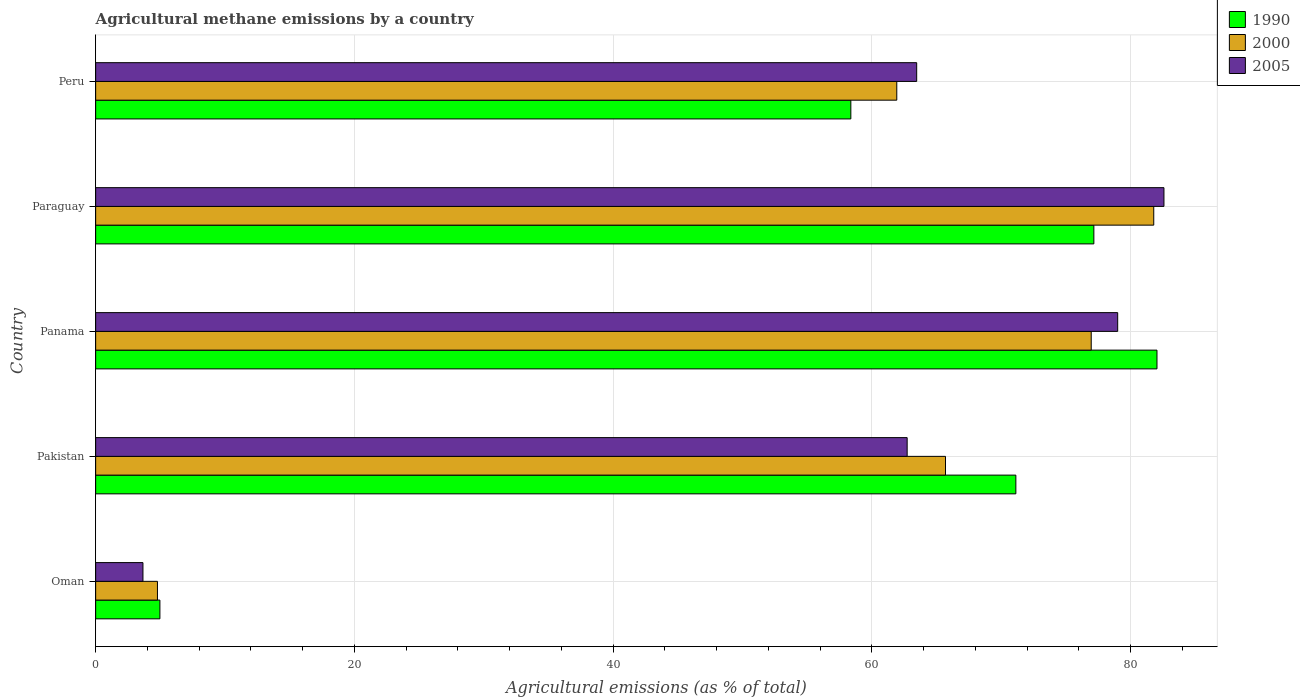How many different coloured bars are there?
Ensure brevity in your answer.  3. How many groups of bars are there?
Give a very brief answer. 5. Are the number of bars per tick equal to the number of legend labels?
Offer a very short reply. Yes. Are the number of bars on each tick of the Y-axis equal?
Your answer should be very brief. Yes. How many bars are there on the 1st tick from the bottom?
Offer a terse response. 3. What is the label of the 3rd group of bars from the top?
Offer a terse response. Panama. What is the amount of agricultural methane emitted in 1990 in Panama?
Provide a succinct answer. 82.04. Across all countries, what is the maximum amount of agricultural methane emitted in 1990?
Ensure brevity in your answer.  82.04. Across all countries, what is the minimum amount of agricultural methane emitted in 2005?
Your answer should be very brief. 3.66. In which country was the amount of agricultural methane emitted in 2000 maximum?
Make the answer very short. Paraguay. In which country was the amount of agricultural methane emitted in 2005 minimum?
Your answer should be very brief. Oman. What is the total amount of agricultural methane emitted in 2000 in the graph?
Provide a short and direct response. 291.14. What is the difference between the amount of agricultural methane emitted in 2005 in Oman and that in Pakistan?
Offer a terse response. -59.07. What is the difference between the amount of agricultural methane emitted in 2000 in Pakistan and the amount of agricultural methane emitted in 2005 in Oman?
Offer a terse response. 62.04. What is the average amount of agricultural methane emitted in 2000 per country?
Your answer should be very brief. 58.23. What is the difference between the amount of agricultural methane emitted in 1990 and amount of agricultural methane emitted in 2005 in Oman?
Your answer should be very brief. 1.31. What is the ratio of the amount of agricultural methane emitted in 1990 in Oman to that in Pakistan?
Your answer should be very brief. 0.07. What is the difference between the highest and the second highest amount of agricultural methane emitted in 2000?
Your answer should be compact. 4.83. What is the difference between the highest and the lowest amount of agricultural methane emitted in 1990?
Ensure brevity in your answer.  77.07. In how many countries, is the amount of agricultural methane emitted in 2000 greater than the average amount of agricultural methane emitted in 2000 taken over all countries?
Your answer should be very brief. 4. Is the sum of the amount of agricultural methane emitted in 2005 in Oman and Pakistan greater than the maximum amount of agricultural methane emitted in 1990 across all countries?
Offer a very short reply. No. What does the 2nd bar from the bottom in Pakistan represents?
Make the answer very short. 2000. How many countries are there in the graph?
Give a very brief answer. 5. What is the difference between two consecutive major ticks on the X-axis?
Provide a short and direct response. 20. Does the graph contain any zero values?
Provide a succinct answer. No. How many legend labels are there?
Your answer should be compact. 3. What is the title of the graph?
Your response must be concise. Agricultural methane emissions by a country. Does "1971" appear as one of the legend labels in the graph?
Offer a very short reply. No. What is the label or title of the X-axis?
Offer a terse response. Agricultural emissions (as % of total). What is the label or title of the Y-axis?
Provide a short and direct response. Country. What is the Agricultural emissions (as % of total) in 1990 in Oman?
Make the answer very short. 4.97. What is the Agricultural emissions (as % of total) of 2000 in Oman?
Offer a very short reply. 4.78. What is the Agricultural emissions (as % of total) in 2005 in Oman?
Offer a very short reply. 3.66. What is the Agricultural emissions (as % of total) of 1990 in Pakistan?
Your response must be concise. 71.13. What is the Agricultural emissions (as % of total) in 2000 in Pakistan?
Your response must be concise. 65.69. What is the Agricultural emissions (as % of total) in 2005 in Pakistan?
Offer a terse response. 62.73. What is the Agricultural emissions (as % of total) of 1990 in Panama?
Your answer should be compact. 82.04. What is the Agricultural emissions (as % of total) in 2000 in Panama?
Provide a short and direct response. 76.96. What is the Agricultural emissions (as % of total) in 2005 in Panama?
Make the answer very short. 79. What is the Agricultural emissions (as % of total) of 1990 in Paraguay?
Your answer should be very brief. 77.16. What is the Agricultural emissions (as % of total) of 2000 in Paraguay?
Provide a succinct answer. 81.79. What is the Agricultural emissions (as % of total) of 2005 in Paraguay?
Provide a short and direct response. 82.58. What is the Agricultural emissions (as % of total) in 1990 in Peru?
Ensure brevity in your answer.  58.38. What is the Agricultural emissions (as % of total) in 2000 in Peru?
Offer a very short reply. 61.93. What is the Agricultural emissions (as % of total) of 2005 in Peru?
Provide a short and direct response. 63.46. Across all countries, what is the maximum Agricultural emissions (as % of total) in 1990?
Ensure brevity in your answer.  82.04. Across all countries, what is the maximum Agricultural emissions (as % of total) of 2000?
Offer a very short reply. 81.79. Across all countries, what is the maximum Agricultural emissions (as % of total) of 2005?
Make the answer very short. 82.58. Across all countries, what is the minimum Agricultural emissions (as % of total) of 1990?
Keep it short and to the point. 4.97. Across all countries, what is the minimum Agricultural emissions (as % of total) of 2000?
Give a very brief answer. 4.78. Across all countries, what is the minimum Agricultural emissions (as % of total) of 2005?
Your response must be concise. 3.66. What is the total Agricultural emissions (as % of total) of 1990 in the graph?
Ensure brevity in your answer.  293.67. What is the total Agricultural emissions (as % of total) of 2000 in the graph?
Make the answer very short. 291.14. What is the total Agricultural emissions (as % of total) in 2005 in the graph?
Make the answer very short. 291.43. What is the difference between the Agricultural emissions (as % of total) in 1990 in Oman and that in Pakistan?
Ensure brevity in your answer.  -66.16. What is the difference between the Agricultural emissions (as % of total) in 2000 in Oman and that in Pakistan?
Provide a succinct answer. -60.92. What is the difference between the Agricultural emissions (as % of total) in 2005 in Oman and that in Pakistan?
Your answer should be very brief. -59.07. What is the difference between the Agricultural emissions (as % of total) of 1990 in Oman and that in Panama?
Your answer should be compact. -77.07. What is the difference between the Agricultural emissions (as % of total) in 2000 in Oman and that in Panama?
Offer a terse response. -72.18. What is the difference between the Agricultural emissions (as % of total) in 2005 in Oman and that in Panama?
Give a very brief answer. -75.35. What is the difference between the Agricultural emissions (as % of total) in 1990 in Oman and that in Paraguay?
Your answer should be very brief. -72.19. What is the difference between the Agricultural emissions (as % of total) in 2000 in Oman and that in Paraguay?
Your answer should be compact. -77.01. What is the difference between the Agricultural emissions (as % of total) in 2005 in Oman and that in Paraguay?
Offer a terse response. -78.92. What is the difference between the Agricultural emissions (as % of total) of 1990 in Oman and that in Peru?
Offer a very short reply. -53.41. What is the difference between the Agricultural emissions (as % of total) in 2000 in Oman and that in Peru?
Keep it short and to the point. -57.15. What is the difference between the Agricultural emissions (as % of total) of 2005 in Oman and that in Peru?
Your answer should be compact. -59.81. What is the difference between the Agricultural emissions (as % of total) in 1990 in Pakistan and that in Panama?
Provide a short and direct response. -10.91. What is the difference between the Agricultural emissions (as % of total) in 2000 in Pakistan and that in Panama?
Your response must be concise. -11.26. What is the difference between the Agricultural emissions (as % of total) in 2005 in Pakistan and that in Panama?
Keep it short and to the point. -16.27. What is the difference between the Agricultural emissions (as % of total) of 1990 in Pakistan and that in Paraguay?
Provide a short and direct response. -6.03. What is the difference between the Agricultural emissions (as % of total) in 2000 in Pakistan and that in Paraguay?
Ensure brevity in your answer.  -16.1. What is the difference between the Agricultural emissions (as % of total) in 2005 in Pakistan and that in Paraguay?
Provide a short and direct response. -19.85. What is the difference between the Agricultural emissions (as % of total) of 1990 in Pakistan and that in Peru?
Give a very brief answer. 12.76. What is the difference between the Agricultural emissions (as % of total) of 2000 in Pakistan and that in Peru?
Your answer should be very brief. 3.77. What is the difference between the Agricultural emissions (as % of total) in 2005 in Pakistan and that in Peru?
Provide a short and direct response. -0.74. What is the difference between the Agricultural emissions (as % of total) in 1990 in Panama and that in Paraguay?
Make the answer very short. 4.88. What is the difference between the Agricultural emissions (as % of total) of 2000 in Panama and that in Paraguay?
Make the answer very short. -4.83. What is the difference between the Agricultural emissions (as % of total) of 2005 in Panama and that in Paraguay?
Ensure brevity in your answer.  -3.58. What is the difference between the Agricultural emissions (as % of total) in 1990 in Panama and that in Peru?
Make the answer very short. 23.66. What is the difference between the Agricultural emissions (as % of total) of 2000 in Panama and that in Peru?
Provide a succinct answer. 15.03. What is the difference between the Agricultural emissions (as % of total) of 2005 in Panama and that in Peru?
Provide a succinct answer. 15.54. What is the difference between the Agricultural emissions (as % of total) in 1990 in Paraguay and that in Peru?
Give a very brief answer. 18.78. What is the difference between the Agricultural emissions (as % of total) in 2000 in Paraguay and that in Peru?
Provide a short and direct response. 19.86. What is the difference between the Agricultural emissions (as % of total) in 2005 in Paraguay and that in Peru?
Your answer should be very brief. 19.11. What is the difference between the Agricultural emissions (as % of total) in 1990 in Oman and the Agricultural emissions (as % of total) in 2000 in Pakistan?
Keep it short and to the point. -60.73. What is the difference between the Agricultural emissions (as % of total) of 1990 in Oman and the Agricultural emissions (as % of total) of 2005 in Pakistan?
Your response must be concise. -57.76. What is the difference between the Agricultural emissions (as % of total) of 2000 in Oman and the Agricultural emissions (as % of total) of 2005 in Pakistan?
Offer a very short reply. -57.95. What is the difference between the Agricultural emissions (as % of total) of 1990 in Oman and the Agricultural emissions (as % of total) of 2000 in Panama?
Offer a terse response. -71.99. What is the difference between the Agricultural emissions (as % of total) in 1990 in Oman and the Agricultural emissions (as % of total) in 2005 in Panama?
Ensure brevity in your answer.  -74.03. What is the difference between the Agricultural emissions (as % of total) in 2000 in Oman and the Agricultural emissions (as % of total) in 2005 in Panama?
Your answer should be compact. -74.23. What is the difference between the Agricultural emissions (as % of total) in 1990 in Oman and the Agricultural emissions (as % of total) in 2000 in Paraguay?
Make the answer very short. -76.82. What is the difference between the Agricultural emissions (as % of total) of 1990 in Oman and the Agricultural emissions (as % of total) of 2005 in Paraguay?
Provide a short and direct response. -77.61. What is the difference between the Agricultural emissions (as % of total) in 2000 in Oman and the Agricultural emissions (as % of total) in 2005 in Paraguay?
Give a very brief answer. -77.8. What is the difference between the Agricultural emissions (as % of total) of 1990 in Oman and the Agricultural emissions (as % of total) of 2000 in Peru?
Make the answer very short. -56.96. What is the difference between the Agricultural emissions (as % of total) of 1990 in Oman and the Agricultural emissions (as % of total) of 2005 in Peru?
Your answer should be very brief. -58.5. What is the difference between the Agricultural emissions (as % of total) in 2000 in Oman and the Agricultural emissions (as % of total) in 2005 in Peru?
Give a very brief answer. -58.69. What is the difference between the Agricultural emissions (as % of total) in 1990 in Pakistan and the Agricultural emissions (as % of total) in 2000 in Panama?
Offer a very short reply. -5.83. What is the difference between the Agricultural emissions (as % of total) of 1990 in Pakistan and the Agricultural emissions (as % of total) of 2005 in Panama?
Your response must be concise. -7.87. What is the difference between the Agricultural emissions (as % of total) of 2000 in Pakistan and the Agricultural emissions (as % of total) of 2005 in Panama?
Your response must be concise. -13.31. What is the difference between the Agricultural emissions (as % of total) of 1990 in Pakistan and the Agricultural emissions (as % of total) of 2000 in Paraguay?
Your response must be concise. -10.66. What is the difference between the Agricultural emissions (as % of total) of 1990 in Pakistan and the Agricultural emissions (as % of total) of 2005 in Paraguay?
Offer a very short reply. -11.45. What is the difference between the Agricultural emissions (as % of total) of 2000 in Pakistan and the Agricultural emissions (as % of total) of 2005 in Paraguay?
Ensure brevity in your answer.  -16.89. What is the difference between the Agricultural emissions (as % of total) in 1990 in Pakistan and the Agricultural emissions (as % of total) in 2000 in Peru?
Provide a succinct answer. 9.2. What is the difference between the Agricultural emissions (as % of total) in 1990 in Pakistan and the Agricultural emissions (as % of total) in 2005 in Peru?
Keep it short and to the point. 7.67. What is the difference between the Agricultural emissions (as % of total) in 2000 in Pakistan and the Agricultural emissions (as % of total) in 2005 in Peru?
Your answer should be very brief. 2.23. What is the difference between the Agricultural emissions (as % of total) of 1990 in Panama and the Agricultural emissions (as % of total) of 2000 in Paraguay?
Offer a very short reply. 0.25. What is the difference between the Agricultural emissions (as % of total) in 1990 in Panama and the Agricultural emissions (as % of total) in 2005 in Paraguay?
Make the answer very short. -0.54. What is the difference between the Agricultural emissions (as % of total) in 2000 in Panama and the Agricultural emissions (as % of total) in 2005 in Paraguay?
Offer a terse response. -5.62. What is the difference between the Agricultural emissions (as % of total) in 1990 in Panama and the Agricultural emissions (as % of total) in 2000 in Peru?
Give a very brief answer. 20.11. What is the difference between the Agricultural emissions (as % of total) in 1990 in Panama and the Agricultural emissions (as % of total) in 2005 in Peru?
Give a very brief answer. 18.58. What is the difference between the Agricultural emissions (as % of total) in 2000 in Panama and the Agricultural emissions (as % of total) in 2005 in Peru?
Your answer should be very brief. 13.49. What is the difference between the Agricultural emissions (as % of total) in 1990 in Paraguay and the Agricultural emissions (as % of total) in 2000 in Peru?
Keep it short and to the point. 15.23. What is the difference between the Agricultural emissions (as % of total) of 1990 in Paraguay and the Agricultural emissions (as % of total) of 2005 in Peru?
Keep it short and to the point. 13.7. What is the difference between the Agricultural emissions (as % of total) of 2000 in Paraguay and the Agricultural emissions (as % of total) of 2005 in Peru?
Provide a succinct answer. 18.33. What is the average Agricultural emissions (as % of total) of 1990 per country?
Give a very brief answer. 58.73. What is the average Agricultural emissions (as % of total) in 2000 per country?
Offer a terse response. 58.23. What is the average Agricultural emissions (as % of total) in 2005 per country?
Provide a short and direct response. 58.29. What is the difference between the Agricultural emissions (as % of total) in 1990 and Agricultural emissions (as % of total) in 2000 in Oman?
Provide a succinct answer. 0.19. What is the difference between the Agricultural emissions (as % of total) of 1990 and Agricultural emissions (as % of total) of 2005 in Oman?
Provide a short and direct response. 1.31. What is the difference between the Agricultural emissions (as % of total) of 2000 and Agricultural emissions (as % of total) of 2005 in Oman?
Provide a succinct answer. 1.12. What is the difference between the Agricultural emissions (as % of total) in 1990 and Agricultural emissions (as % of total) in 2000 in Pakistan?
Offer a very short reply. 5.44. What is the difference between the Agricultural emissions (as % of total) of 1990 and Agricultural emissions (as % of total) of 2005 in Pakistan?
Ensure brevity in your answer.  8.4. What is the difference between the Agricultural emissions (as % of total) in 2000 and Agricultural emissions (as % of total) in 2005 in Pakistan?
Give a very brief answer. 2.96. What is the difference between the Agricultural emissions (as % of total) of 1990 and Agricultural emissions (as % of total) of 2000 in Panama?
Your response must be concise. 5.08. What is the difference between the Agricultural emissions (as % of total) of 1990 and Agricultural emissions (as % of total) of 2005 in Panama?
Ensure brevity in your answer.  3.04. What is the difference between the Agricultural emissions (as % of total) in 2000 and Agricultural emissions (as % of total) in 2005 in Panama?
Your answer should be very brief. -2.04. What is the difference between the Agricultural emissions (as % of total) of 1990 and Agricultural emissions (as % of total) of 2000 in Paraguay?
Offer a terse response. -4.63. What is the difference between the Agricultural emissions (as % of total) of 1990 and Agricultural emissions (as % of total) of 2005 in Paraguay?
Ensure brevity in your answer.  -5.42. What is the difference between the Agricultural emissions (as % of total) of 2000 and Agricultural emissions (as % of total) of 2005 in Paraguay?
Your answer should be compact. -0.79. What is the difference between the Agricultural emissions (as % of total) of 1990 and Agricultural emissions (as % of total) of 2000 in Peru?
Make the answer very short. -3.55. What is the difference between the Agricultural emissions (as % of total) of 1990 and Agricultural emissions (as % of total) of 2005 in Peru?
Provide a succinct answer. -5.09. What is the difference between the Agricultural emissions (as % of total) of 2000 and Agricultural emissions (as % of total) of 2005 in Peru?
Make the answer very short. -1.54. What is the ratio of the Agricultural emissions (as % of total) in 1990 in Oman to that in Pakistan?
Ensure brevity in your answer.  0.07. What is the ratio of the Agricultural emissions (as % of total) of 2000 in Oman to that in Pakistan?
Provide a short and direct response. 0.07. What is the ratio of the Agricultural emissions (as % of total) of 2005 in Oman to that in Pakistan?
Provide a short and direct response. 0.06. What is the ratio of the Agricultural emissions (as % of total) in 1990 in Oman to that in Panama?
Make the answer very short. 0.06. What is the ratio of the Agricultural emissions (as % of total) in 2000 in Oman to that in Panama?
Give a very brief answer. 0.06. What is the ratio of the Agricultural emissions (as % of total) in 2005 in Oman to that in Panama?
Provide a short and direct response. 0.05. What is the ratio of the Agricultural emissions (as % of total) in 1990 in Oman to that in Paraguay?
Offer a terse response. 0.06. What is the ratio of the Agricultural emissions (as % of total) of 2000 in Oman to that in Paraguay?
Offer a terse response. 0.06. What is the ratio of the Agricultural emissions (as % of total) in 2005 in Oman to that in Paraguay?
Your answer should be compact. 0.04. What is the ratio of the Agricultural emissions (as % of total) in 1990 in Oman to that in Peru?
Your answer should be very brief. 0.09. What is the ratio of the Agricultural emissions (as % of total) in 2000 in Oman to that in Peru?
Provide a succinct answer. 0.08. What is the ratio of the Agricultural emissions (as % of total) in 2005 in Oman to that in Peru?
Ensure brevity in your answer.  0.06. What is the ratio of the Agricultural emissions (as % of total) of 1990 in Pakistan to that in Panama?
Provide a succinct answer. 0.87. What is the ratio of the Agricultural emissions (as % of total) in 2000 in Pakistan to that in Panama?
Your answer should be very brief. 0.85. What is the ratio of the Agricultural emissions (as % of total) of 2005 in Pakistan to that in Panama?
Offer a terse response. 0.79. What is the ratio of the Agricultural emissions (as % of total) of 1990 in Pakistan to that in Paraguay?
Offer a terse response. 0.92. What is the ratio of the Agricultural emissions (as % of total) of 2000 in Pakistan to that in Paraguay?
Ensure brevity in your answer.  0.8. What is the ratio of the Agricultural emissions (as % of total) in 2005 in Pakistan to that in Paraguay?
Give a very brief answer. 0.76. What is the ratio of the Agricultural emissions (as % of total) of 1990 in Pakistan to that in Peru?
Ensure brevity in your answer.  1.22. What is the ratio of the Agricultural emissions (as % of total) in 2000 in Pakistan to that in Peru?
Keep it short and to the point. 1.06. What is the ratio of the Agricultural emissions (as % of total) in 2005 in Pakistan to that in Peru?
Your answer should be very brief. 0.99. What is the ratio of the Agricultural emissions (as % of total) of 1990 in Panama to that in Paraguay?
Provide a short and direct response. 1.06. What is the ratio of the Agricultural emissions (as % of total) in 2000 in Panama to that in Paraguay?
Your response must be concise. 0.94. What is the ratio of the Agricultural emissions (as % of total) of 2005 in Panama to that in Paraguay?
Offer a terse response. 0.96. What is the ratio of the Agricultural emissions (as % of total) of 1990 in Panama to that in Peru?
Your response must be concise. 1.41. What is the ratio of the Agricultural emissions (as % of total) in 2000 in Panama to that in Peru?
Your response must be concise. 1.24. What is the ratio of the Agricultural emissions (as % of total) in 2005 in Panama to that in Peru?
Keep it short and to the point. 1.24. What is the ratio of the Agricultural emissions (as % of total) of 1990 in Paraguay to that in Peru?
Keep it short and to the point. 1.32. What is the ratio of the Agricultural emissions (as % of total) in 2000 in Paraguay to that in Peru?
Keep it short and to the point. 1.32. What is the ratio of the Agricultural emissions (as % of total) of 2005 in Paraguay to that in Peru?
Your answer should be compact. 1.3. What is the difference between the highest and the second highest Agricultural emissions (as % of total) of 1990?
Give a very brief answer. 4.88. What is the difference between the highest and the second highest Agricultural emissions (as % of total) in 2000?
Your answer should be very brief. 4.83. What is the difference between the highest and the second highest Agricultural emissions (as % of total) of 2005?
Your response must be concise. 3.58. What is the difference between the highest and the lowest Agricultural emissions (as % of total) in 1990?
Offer a very short reply. 77.07. What is the difference between the highest and the lowest Agricultural emissions (as % of total) in 2000?
Make the answer very short. 77.01. What is the difference between the highest and the lowest Agricultural emissions (as % of total) in 2005?
Provide a short and direct response. 78.92. 